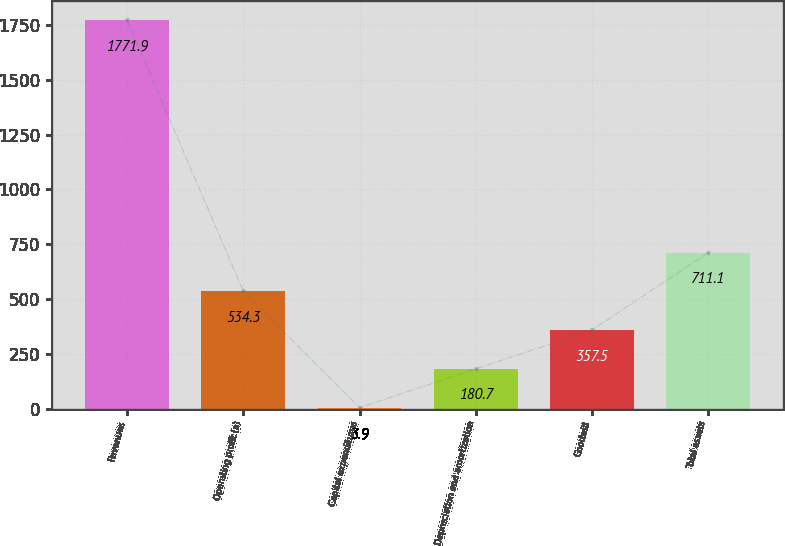Convert chart to OTSL. <chart><loc_0><loc_0><loc_500><loc_500><bar_chart><fcel>Revenues<fcel>Operating profit (a)<fcel>Capital expenditures<fcel>Depreciation and amortization<fcel>Goodwill<fcel>Total assets<nl><fcel>1771.9<fcel>534.3<fcel>3.9<fcel>180.7<fcel>357.5<fcel>711.1<nl></chart> 